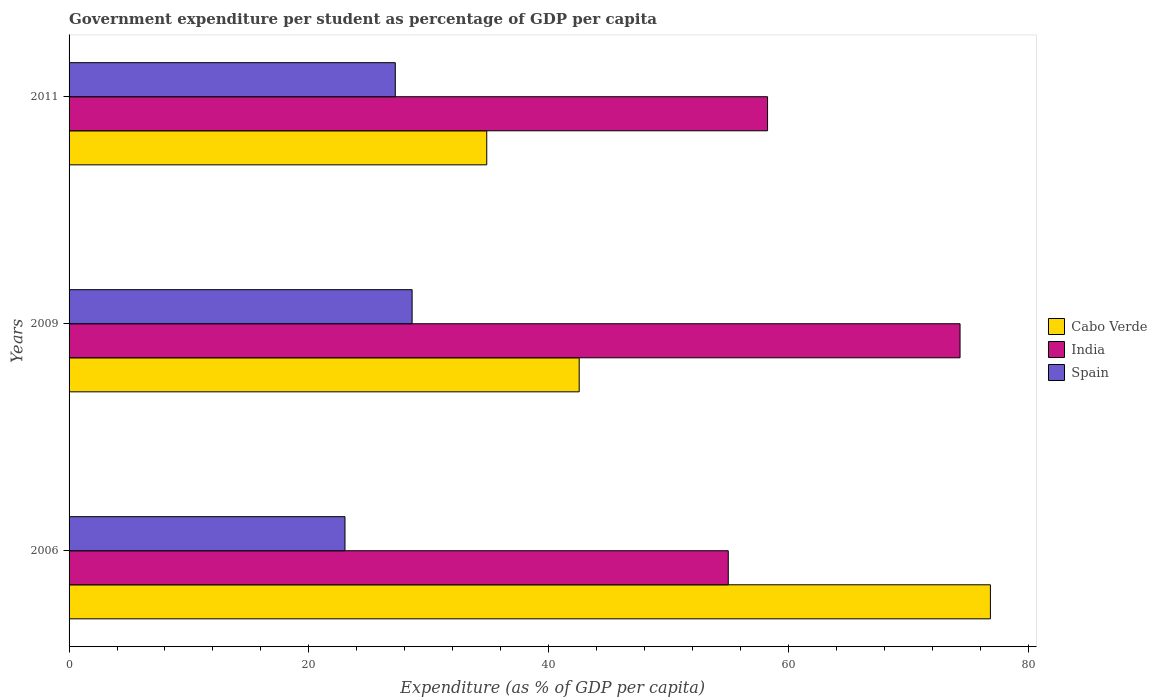Are the number of bars per tick equal to the number of legend labels?
Your answer should be compact. Yes. How many bars are there on the 1st tick from the top?
Offer a terse response. 3. How many bars are there on the 2nd tick from the bottom?
Give a very brief answer. 3. In how many cases, is the number of bars for a given year not equal to the number of legend labels?
Offer a very short reply. 0. What is the percentage of expenditure per student in India in 2011?
Ensure brevity in your answer.  58.26. Across all years, what is the maximum percentage of expenditure per student in India?
Your response must be concise. 74.31. Across all years, what is the minimum percentage of expenditure per student in Cabo Verde?
Provide a short and direct response. 34.84. In which year was the percentage of expenditure per student in Cabo Verde maximum?
Keep it short and to the point. 2006. What is the total percentage of expenditure per student in India in the graph?
Your response must be concise. 187.55. What is the difference between the percentage of expenditure per student in India in 2006 and that in 2011?
Offer a terse response. -3.28. What is the difference between the percentage of expenditure per student in Spain in 2006 and the percentage of expenditure per student in Cabo Verde in 2011?
Make the answer very short. -11.82. What is the average percentage of expenditure per student in Cabo Verde per year?
Ensure brevity in your answer.  51.41. In the year 2009, what is the difference between the percentage of expenditure per student in Cabo Verde and percentage of expenditure per student in Spain?
Keep it short and to the point. 13.94. In how many years, is the percentage of expenditure per student in Spain greater than 40 %?
Ensure brevity in your answer.  0. What is the ratio of the percentage of expenditure per student in Spain in 2006 to that in 2011?
Your answer should be compact. 0.85. What is the difference between the highest and the second highest percentage of expenditure per student in India?
Keep it short and to the point. 16.05. What is the difference between the highest and the lowest percentage of expenditure per student in Spain?
Your response must be concise. 5.6. Is the sum of the percentage of expenditure per student in Cabo Verde in 2006 and 2011 greater than the maximum percentage of expenditure per student in India across all years?
Your answer should be very brief. Yes. What does the 1st bar from the top in 2006 represents?
Provide a short and direct response. Spain. Is it the case that in every year, the sum of the percentage of expenditure per student in Spain and percentage of expenditure per student in Cabo Verde is greater than the percentage of expenditure per student in India?
Ensure brevity in your answer.  No. Are all the bars in the graph horizontal?
Your answer should be very brief. Yes. Are the values on the major ticks of X-axis written in scientific E-notation?
Provide a short and direct response. No. How many legend labels are there?
Your answer should be compact. 3. How are the legend labels stacked?
Keep it short and to the point. Vertical. What is the title of the graph?
Provide a succinct answer. Government expenditure per student as percentage of GDP per capita. Does "Ethiopia" appear as one of the legend labels in the graph?
Make the answer very short. No. What is the label or title of the X-axis?
Offer a terse response. Expenditure (as % of GDP per capita). What is the label or title of the Y-axis?
Ensure brevity in your answer.  Years. What is the Expenditure (as % of GDP per capita) of Cabo Verde in 2006?
Make the answer very short. 76.84. What is the Expenditure (as % of GDP per capita) in India in 2006?
Your answer should be compact. 54.98. What is the Expenditure (as % of GDP per capita) of Spain in 2006?
Ensure brevity in your answer.  23.01. What is the Expenditure (as % of GDP per capita) in Cabo Verde in 2009?
Your answer should be compact. 42.55. What is the Expenditure (as % of GDP per capita) of India in 2009?
Give a very brief answer. 74.31. What is the Expenditure (as % of GDP per capita) of Spain in 2009?
Your response must be concise. 28.61. What is the Expenditure (as % of GDP per capita) in Cabo Verde in 2011?
Keep it short and to the point. 34.84. What is the Expenditure (as % of GDP per capita) of India in 2011?
Your answer should be compact. 58.26. What is the Expenditure (as % of GDP per capita) in Spain in 2011?
Your answer should be very brief. 27.21. Across all years, what is the maximum Expenditure (as % of GDP per capita) of Cabo Verde?
Offer a terse response. 76.84. Across all years, what is the maximum Expenditure (as % of GDP per capita) of India?
Give a very brief answer. 74.31. Across all years, what is the maximum Expenditure (as % of GDP per capita) of Spain?
Provide a short and direct response. 28.61. Across all years, what is the minimum Expenditure (as % of GDP per capita) in Cabo Verde?
Your answer should be very brief. 34.84. Across all years, what is the minimum Expenditure (as % of GDP per capita) of India?
Keep it short and to the point. 54.98. Across all years, what is the minimum Expenditure (as % of GDP per capita) of Spain?
Your response must be concise. 23.01. What is the total Expenditure (as % of GDP per capita) in Cabo Verde in the graph?
Provide a succinct answer. 154.22. What is the total Expenditure (as % of GDP per capita) of India in the graph?
Provide a short and direct response. 187.55. What is the total Expenditure (as % of GDP per capita) in Spain in the graph?
Your response must be concise. 78.83. What is the difference between the Expenditure (as % of GDP per capita) of Cabo Verde in 2006 and that in 2009?
Provide a succinct answer. 34.3. What is the difference between the Expenditure (as % of GDP per capita) of India in 2006 and that in 2009?
Provide a short and direct response. -19.33. What is the difference between the Expenditure (as % of GDP per capita) of Spain in 2006 and that in 2009?
Provide a succinct answer. -5.6. What is the difference between the Expenditure (as % of GDP per capita) in Cabo Verde in 2006 and that in 2011?
Give a very brief answer. 42.01. What is the difference between the Expenditure (as % of GDP per capita) of India in 2006 and that in 2011?
Provide a short and direct response. -3.28. What is the difference between the Expenditure (as % of GDP per capita) in Spain in 2006 and that in 2011?
Your answer should be compact. -4.2. What is the difference between the Expenditure (as % of GDP per capita) in Cabo Verde in 2009 and that in 2011?
Provide a short and direct response. 7.71. What is the difference between the Expenditure (as % of GDP per capita) of India in 2009 and that in 2011?
Your answer should be compact. 16.05. What is the difference between the Expenditure (as % of GDP per capita) in Spain in 2009 and that in 2011?
Keep it short and to the point. 1.4. What is the difference between the Expenditure (as % of GDP per capita) of Cabo Verde in 2006 and the Expenditure (as % of GDP per capita) of India in 2009?
Keep it short and to the point. 2.53. What is the difference between the Expenditure (as % of GDP per capita) in Cabo Verde in 2006 and the Expenditure (as % of GDP per capita) in Spain in 2009?
Provide a short and direct response. 48.23. What is the difference between the Expenditure (as % of GDP per capita) of India in 2006 and the Expenditure (as % of GDP per capita) of Spain in 2009?
Offer a very short reply. 26.37. What is the difference between the Expenditure (as % of GDP per capita) in Cabo Verde in 2006 and the Expenditure (as % of GDP per capita) in India in 2011?
Keep it short and to the point. 18.59. What is the difference between the Expenditure (as % of GDP per capita) in Cabo Verde in 2006 and the Expenditure (as % of GDP per capita) in Spain in 2011?
Provide a short and direct response. 49.63. What is the difference between the Expenditure (as % of GDP per capita) in India in 2006 and the Expenditure (as % of GDP per capita) in Spain in 2011?
Provide a succinct answer. 27.77. What is the difference between the Expenditure (as % of GDP per capita) in Cabo Verde in 2009 and the Expenditure (as % of GDP per capita) in India in 2011?
Make the answer very short. -15.71. What is the difference between the Expenditure (as % of GDP per capita) of Cabo Verde in 2009 and the Expenditure (as % of GDP per capita) of Spain in 2011?
Keep it short and to the point. 15.34. What is the difference between the Expenditure (as % of GDP per capita) in India in 2009 and the Expenditure (as % of GDP per capita) in Spain in 2011?
Provide a short and direct response. 47.1. What is the average Expenditure (as % of GDP per capita) of Cabo Verde per year?
Your response must be concise. 51.41. What is the average Expenditure (as % of GDP per capita) in India per year?
Your response must be concise. 62.52. What is the average Expenditure (as % of GDP per capita) in Spain per year?
Keep it short and to the point. 26.28. In the year 2006, what is the difference between the Expenditure (as % of GDP per capita) in Cabo Verde and Expenditure (as % of GDP per capita) in India?
Give a very brief answer. 21.86. In the year 2006, what is the difference between the Expenditure (as % of GDP per capita) in Cabo Verde and Expenditure (as % of GDP per capita) in Spain?
Ensure brevity in your answer.  53.83. In the year 2006, what is the difference between the Expenditure (as % of GDP per capita) in India and Expenditure (as % of GDP per capita) in Spain?
Offer a very short reply. 31.97. In the year 2009, what is the difference between the Expenditure (as % of GDP per capita) in Cabo Verde and Expenditure (as % of GDP per capita) in India?
Make the answer very short. -31.77. In the year 2009, what is the difference between the Expenditure (as % of GDP per capita) of Cabo Verde and Expenditure (as % of GDP per capita) of Spain?
Make the answer very short. 13.94. In the year 2009, what is the difference between the Expenditure (as % of GDP per capita) in India and Expenditure (as % of GDP per capita) in Spain?
Your answer should be very brief. 45.7. In the year 2011, what is the difference between the Expenditure (as % of GDP per capita) in Cabo Verde and Expenditure (as % of GDP per capita) in India?
Provide a short and direct response. -23.42. In the year 2011, what is the difference between the Expenditure (as % of GDP per capita) in Cabo Verde and Expenditure (as % of GDP per capita) in Spain?
Give a very brief answer. 7.63. In the year 2011, what is the difference between the Expenditure (as % of GDP per capita) in India and Expenditure (as % of GDP per capita) in Spain?
Provide a succinct answer. 31.05. What is the ratio of the Expenditure (as % of GDP per capita) of Cabo Verde in 2006 to that in 2009?
Make the answer very short. 1.81. What is the ratio of the Expenditure (as % of GDP per capita) of India in 2006 to that in 2009?
Ensure brevity in your answer.  0.74. What is the ratio of the Expenditure (as % of GDP per capita) of Spain in 2006 to that in 2009?
Your answer should be compact. 0.8. What is the ratio of the Expenditure (as % of GDP per capita) in Cabo Verde in 2006 to that in 2011?
Make the answer very short. 2.21. What is the ratio of the Expenditure (as % of GDP per capita) of India in 2006 to that in 2011?
Keep it short and to the point. 0.94. What is the ratio of the Expenditure (as % of GDP per capita) in Spain in 2006 to that in 2011?
Offer a very short reply. 0.85. What is the ratio of the Expenditure (as % of GDP per capita) in Cabo Verde in 2009 to that in 2011?
Offer a very short reply. 1.22. What is the ratio of the Expenditure (as % of GDP per capita) of India in 2009 to that in 2011?
Your response must be concise. 1.28. What is the ratio of the Expenditure (as % of GDP per capita) in Spain in 2009 to that in 2011?
Offer a terse response. 1.05. What is the difference between the highest and the second highest Expenditure (as % of GDP per capita) in Cabo Verde?
Provide a succinct answer. 34.3. What is the difference between the highest and the second highest Expenditure (as % of GDP per capita) in India?
Offer a terse response. 16.05. What is the difference between the highest and the second highest Expenditure (as % of GDP per capita) in Spain?
Your answer should be compact. 1.4. What is the difference between the highest and the lowest Expenditure (as % of GDP per capita) in Cabo Verde?
Keep it short and to the point. 42.01. What is the difference between the highest and the lowest Expenditure (as % of GDP per capita) in India?
Your answer should be compact. 19.33. What is the difference between the highest and the lowest Expenditure (as % of GDP per capita) in Spain?
Your answer should be compact. 5.6. 